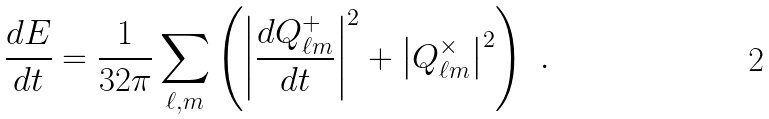Convert formula to latex. <formula><loc_0><loc_0><loc_500><loc_500>\frac { d E } { d t } = \frac { 1 } { 3 2 \pi } \sum _ { \ell , m } \left ( \left | \frac { d { Q } ^ { + } _ { \ell m } } { d t } \right | ^ { 2 } + \left | Q ^ { \times } _ { \ell m } \right | ^ { 2 } \right ) \ .</formula> 